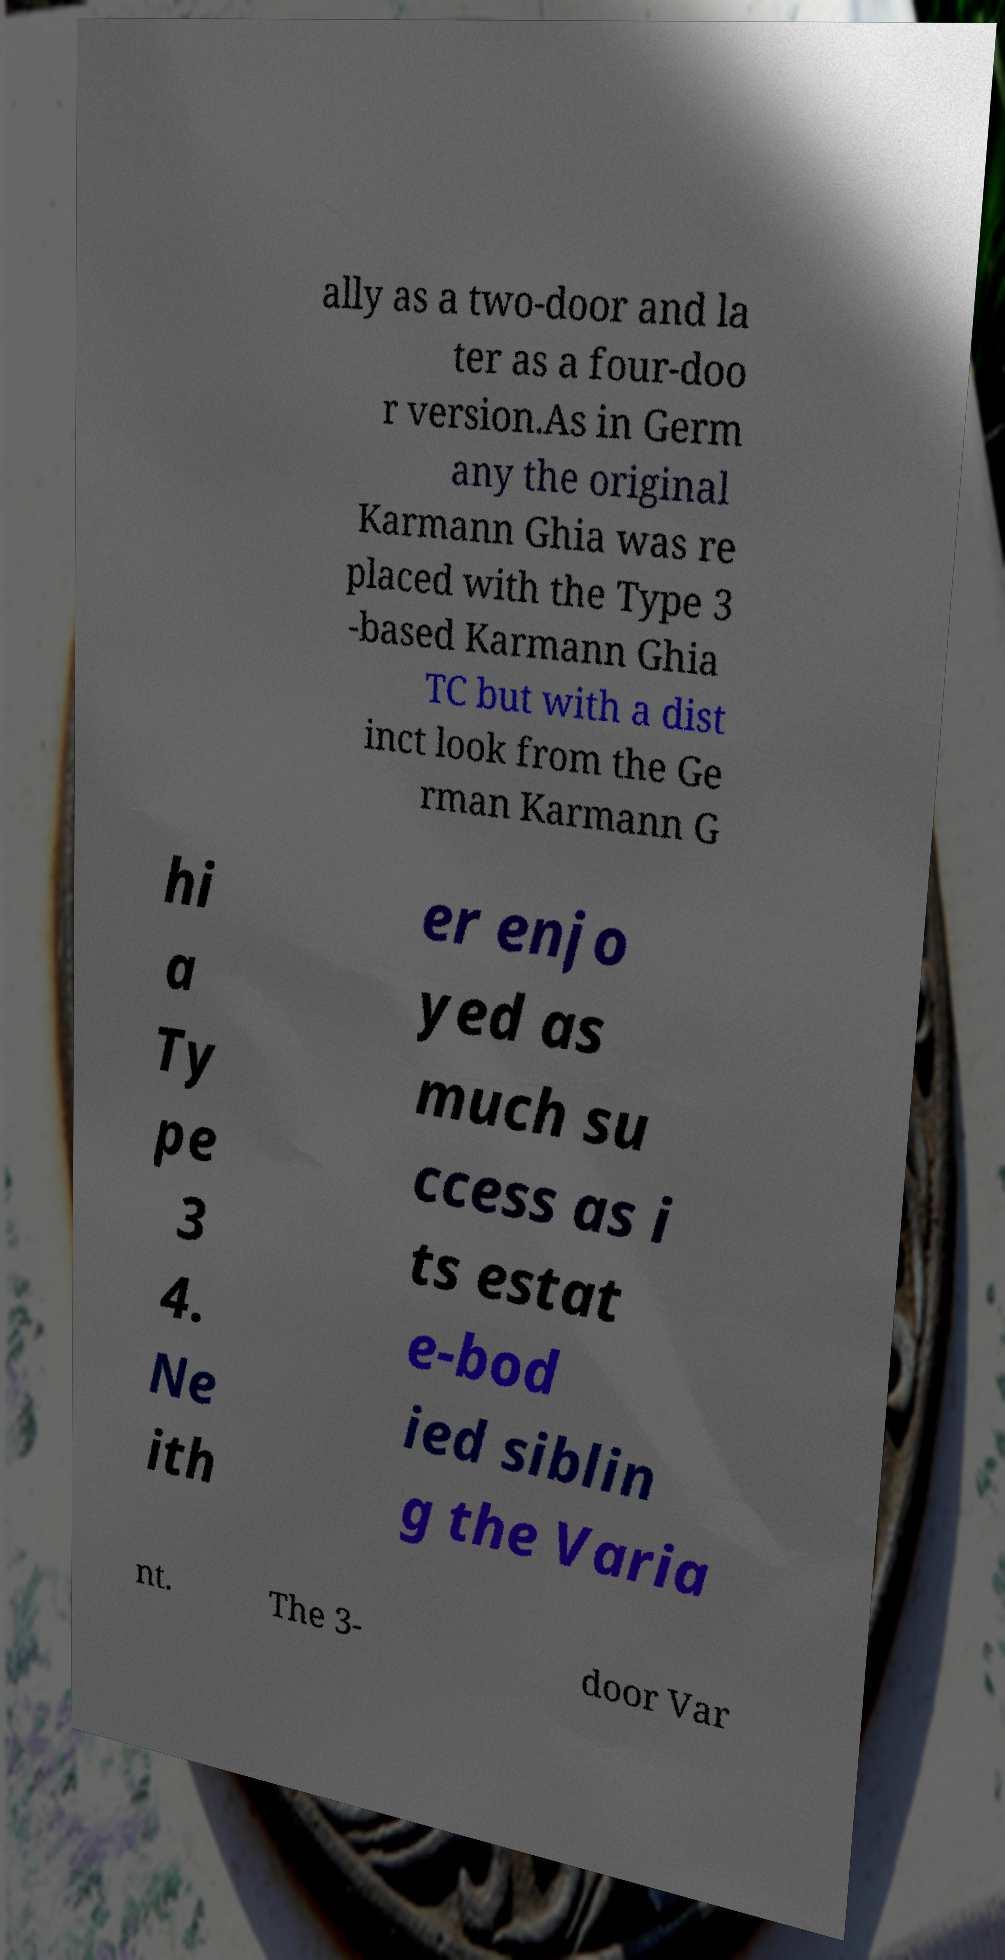Could you extract and type out the text from this image? ally as a two-door and la ter as a four-doo r version.As in Germ any the original Karmann Ghia was re placed with the Type 3 -based Karmann Ghia TC but with a dist inct look from the Ge rman Karmann G hi a Ty pe 3 4. Ne ith er enjo yed as much su ccess as i ts estat e-bod ied siblin g the Varia nt. The 3- door Var 